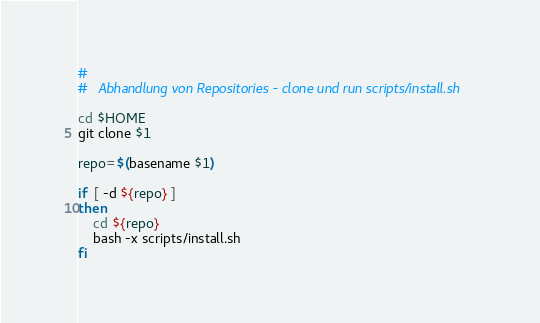Convert code to text. <code><loc_0><loc_0><loc_500><loc_500><_Bash_>#
#   Abhandlung von Repositories - clone und run scripts/install.sh

cd $HOME
git clone $1

repo=$(basename $1)

if  [ -d ${repo} ]
then
    cd ${repo}
    bash -x scripts/install.sh
fi</code> 